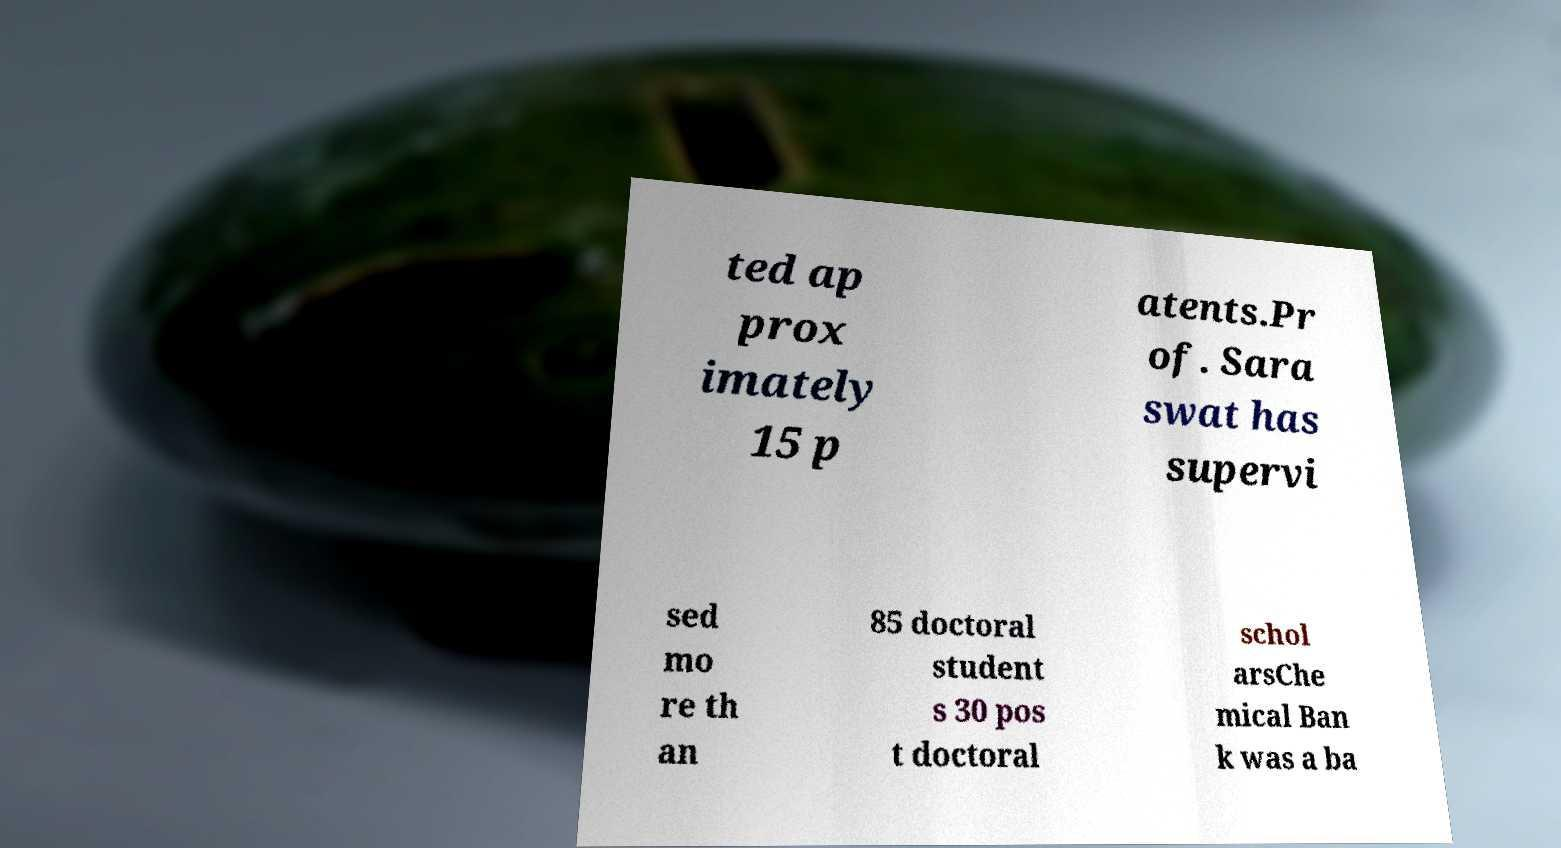For documentation purposes, I need the text within this image transcribed. Could you provide that? ted ap prox imately 15 p atents.Pr of. Sara swat has supervi sed mo re th an 85 doctoral student s 30 pos t doctoral schol arsChe mical Ban k was a ba 